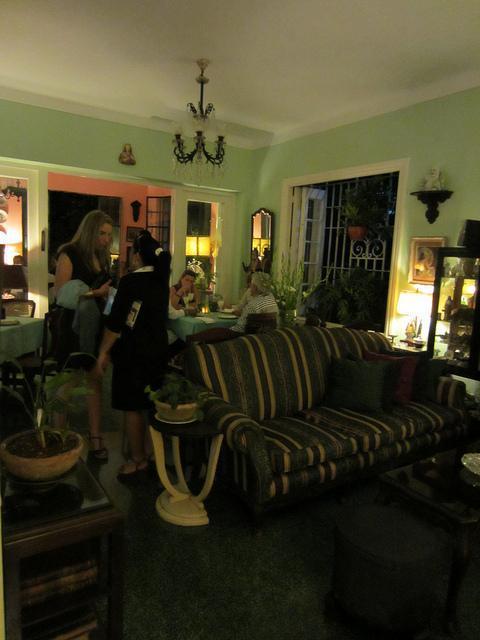How many people are in the photo?
Give a very brief answer. 2. How many couches are there?
Give a very brief answer. 1. How many potted plants can you see?
Give a very brief answer. 4. How many bears are seen to the left of the tree?
Give a very brief answer. 0. 